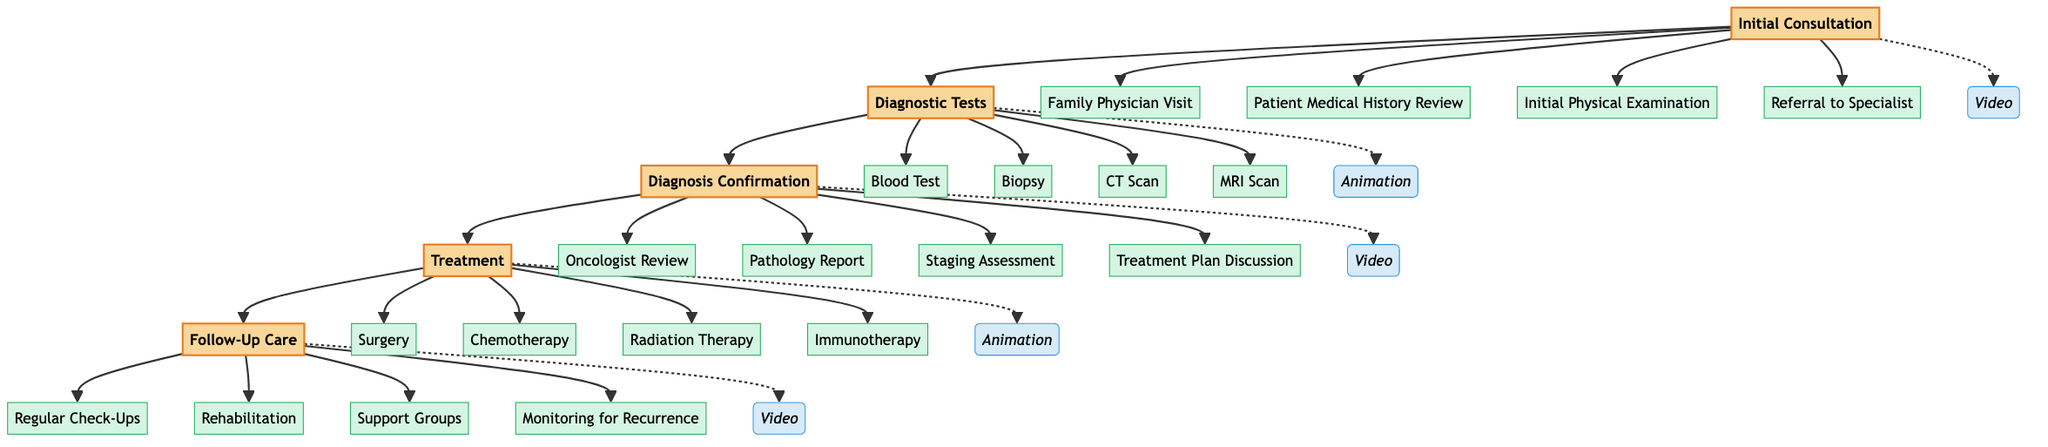What is the first stage of the clinical pathway? The diagram indicates that the first stage in the clinical pathway is labeled as "Initial Consultation".
Answer: Initial Consultation How many components are included in the "Treatment" stage? By inspecting the "Treatment" stage, we see it lists four components: Surgery, Chemotherapy, Radiation Therapy, and Immunotherapy. Hence, there are 4 components.
Answer: 4 Which media type is used for the "Diagnostic Tests" stage? The diagram shows that the "Diagnostic Tests" stage utilizes animation as its media type.
Answer: animation What is the last component of the "Follow-Up Care" stage? The last component listed under "Follow-Up Care" is "Monitoring for Recurrence", which is the final item in that stage.
Answer: Monitoring for Recurrence In which stage does the "Oncologist Review" occur? Upon examining the connections between the stages, we find that "Oncologist Review" is part of the "Diagnosis Confirmation" stage.
Answer: Diagnosis Confirmation How many stages are there in total within the clinical pathway? Counting from the diagram, we can see that there are five distinct stages: Initial Consultation, Diagnostic Tests, Diagnosis Confirmation, Treatment, and Follow-Up Care. This results in a total of 5 stages.
Answer: 5 What is the relationship between "Initial Consultation" and "Diagnostic Tests"? The diagram illustrates a direct flow from "Initial Consultation" to "Diagnostic Tests", indicating that the former leads into the latter stage as part of the patient journey.
Answer: leads to What type of media is used for the "Diagnosis Confirmation" stage? The diagram specifies that the "Diagnosis Confirmation" stage uses video as its media type for presenting information.
Answer: video Which step follows directly after "Biopsy"? The clinical pathway flows from "Biopsy" to "CT Scan", meaning "CT Scan" is the next step that occurs right after "Biopsy".
Answer: CT Scan 